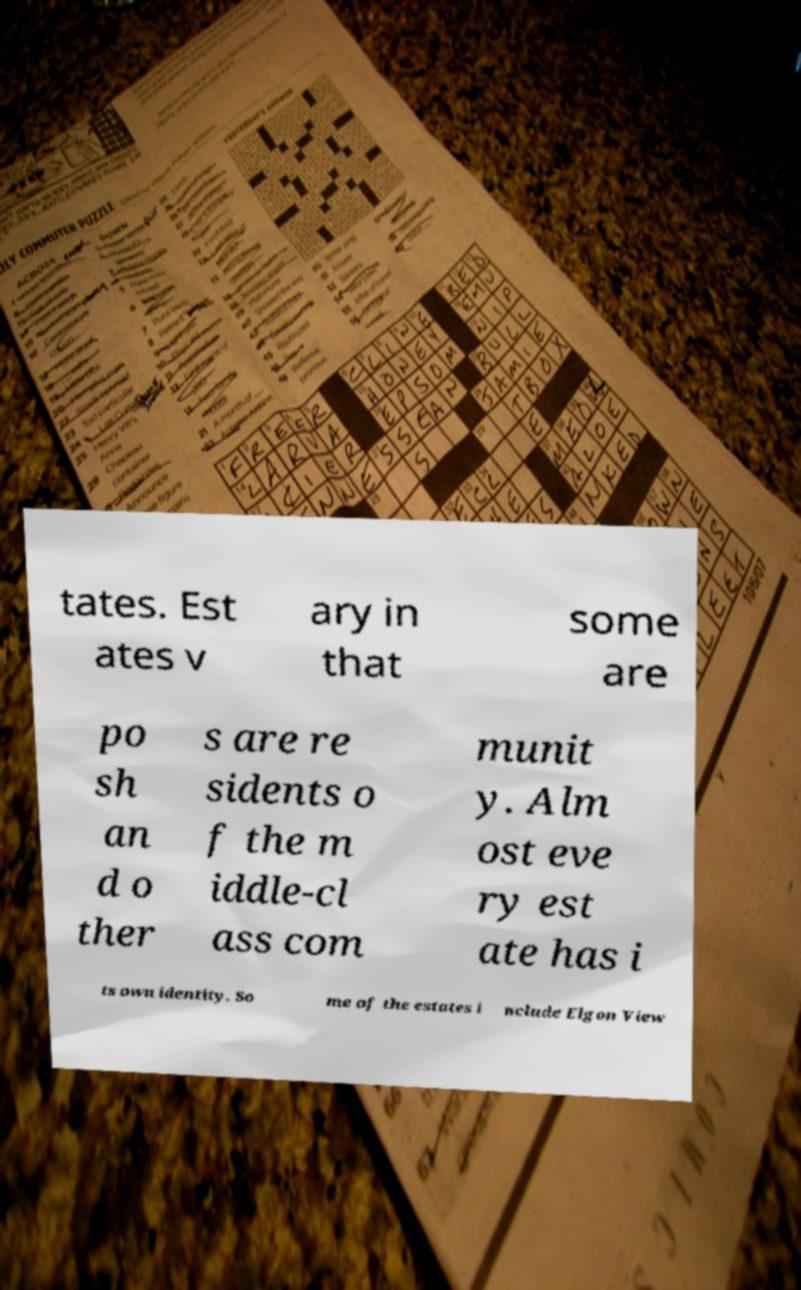Could you extract and type out the text from this image? tates. Est ates v ary in that some are po sh an d o ther s are re sidents o f the m iddle-cl ass com munit y. Alm ost eve ry est ate has i ts own identity. So me of the estates i nclude Elgon View 